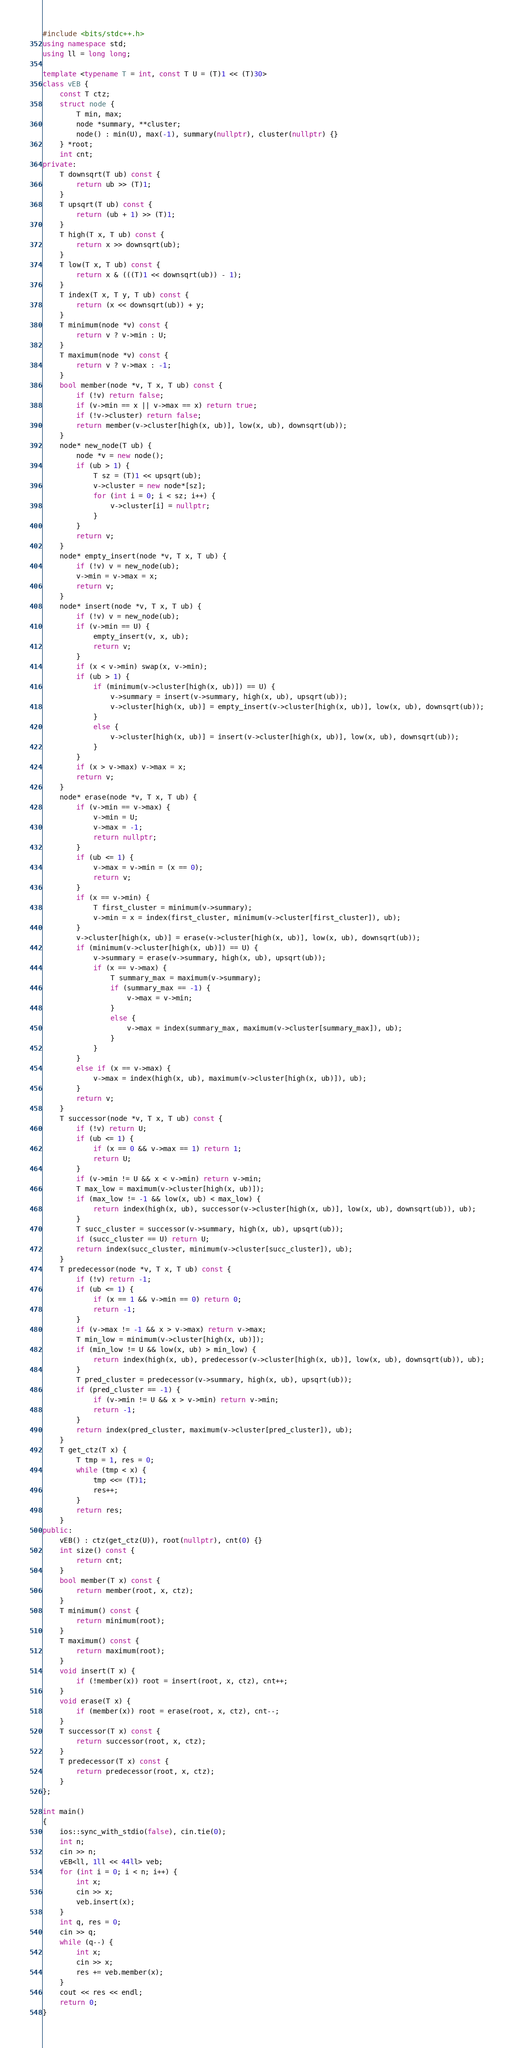Convert code to text. <code><loc_0><loc_0><loc_500><loc_500><_C++_>#include <bits/stdc++.h>
using namespace std;
using ll = long long;

template <typename T = int, const T U = (T)1 << (T)30>
class vEB {
	const T ctz;
	struct node {
		T min, max;
		node *summary, **cluster;
		node() : min(U), max(-1), summary(nullptr), cluster(nullptr) {}
	} *root;
	int cnt;
private:
	T downsqrt(T ub) const {
		return ub >> (T)1;
	}
	T upsqrt(T ub) const {
		return (ub + 1) >> (T)1;
	}
	T high(T x, T ub) const {
		return x >> downsqrt(ub);
	}
	T low(T x, T ub) const {
		return x & (((T)1 << downsqrt(ub)) - 1);
	}
	T index(T x, T y, T ub) const {
		return (x << downsqrt(ub)) + y;
	}
	T minimum(node *v) const {
		return v ? v->min : U;
	}
	T maximum(node *v) const {
		return v ? v->max : -1;
	}
	bool member(node *v, T x, T ub) const {
		if (!v) return false;
		if (v->min == x || v->max == x) return true;
		if (!v->cluster) return false;
		return member(v->cluster[high(x, ub)], low(x, ub), downsqrt(ub));
	}
	node* new_node(T ub) {
		node *v = new node();
		if (ub > 1) {
			T sz = (T)1 << upsqrt(ub);
			v->cluster = new node*[sz];
			for (int i = 0; i < sz; i++) {
				v->cluster[i] = nullptr;
			}
		}
		return v;
	}
	node* empty_insert(node *v, T x, T ub) {
		if (!v) v = new_node(ub);
		v->min = v->max = x;
		return v;
	}
	node* insert(node *v, T x, T ub) {
		if (!v) v = new_node(ub);
		if (v->min == U) {
			empty_insert(v, x, ub);
			return v;
		}
		if (x < v->min) swap(x, v->min);
		if (ub > 1) {
			if (minimum(v->cluster[high(x, ub)]) == U) {
				v->summary = insert(v->summary, high(x, ub), upsqrt(ub));
				v->cluster[high(x, ub)] = empty_insert(v->cluster[high(x, ub)], low(x, ub), downsqrt(ub));
			}
			else {
				v->cluster[high(x, ub)] = insert(v->cluster[high(x, ub)], low(x, ub), downsqrt(ub));
			}
		}
		if (x > v->max) v->max = x;
		return v;
	}
	node* erase(node *v, T x, T ub) {
		if (v->min == v->max) {
			v->min = U;
			v->max = -1;
			return nullptr;
		}
		if (ub <= 1) {
			v->max = v->min = (x == 0);
			return v;
		}
		if (x == v->min) {
			T first_cluster = minimum(v->summary);
			v->min = x = index(first_cluster, minimum(v->cluster[first_cluster]), ub);
		}
		v->cluster[high(x, ub)] = erase(v->cluster[high(x, ub)], low(x, ub), downsqrt(ub));
		if (minimum(v->cluster[high(x, ub)]) == U) {
			v->summary = erase(v->summary, high(x, ub), upsqrt(ub));
			if (x == v->max) {
				T summary_max = maximum(v->summary);
				if (summary_max == -1) {
					v->max = v->min;
				}
				else {
					v->max = index(summary_max, maximum(v->cluster[summary_max]), ub);
				}
			}
		}
		else if (x == v->max) {
			v->max = index(high(x, ub), maximum(v->cluster[high(x, ub)]), ub);
		}
		return v;
	}
	T successor(node *v, T x, T ub) const {
		if (!v) return U;
		if (ub <= 1) {
			if (x == 0 && v->max == 1) return 1;
			return U;
		}
		if (v->min != U && x < v->min) return v->min;
		T max_low = maximum(v->cluster[high(x, ub)]);
		if (max_low != -1 && low(x, ub) < max_low) {
			return index(high(x, ub), successor(v->cluster[high(x, ub)], low(x, ub), downsqrt(ub)), ub);
		}
		T succ_cluster = successor(v->summary, high(x, ub), upsqrt(ub));
		if (succ_cluster == U) return U;
		return index(succ_cluster, minimum(v->cluster[succ_cluster]), ub);
	}
	T predecessor(node *v, T x, T ub) const {
		if (!v) return -1;
		if (ub <= 1) {
			if (x == 1 && v->min == 0) return 0;
			return -1;
		}
		if (v->max != -1 && x > v->max) return v->max;
		T min_low = minimum(v->cluster[high(x, ub)]);
		if (min_low != U && low(x, ub) > min_low) {
			return index(high(x, ub), predecessor(v->cluster[high(x, ub)], low(x, ub), downsqrt(ub)), ub);
		}
		T pred_cluster = predecessor(v->summary, high(x, ub), upsqrt(ub));
		if (pred_cluster == -1) {
			if (v->min != U && x > v->min) return v->min;
			return -1;
		}
		return index(pred_cluster, maximum(v->cluster[pred_cluster]), ub);
	}
	T get_ctz(T x) {
		T tmp = 1, res = 0;
		while (tmp < x) {
			tmp <<= (T)1;
			res++;
		}
		return res;
	}
public:
	vEB() : ctz(get_ctz(U)), root(nullptr), cnt(0) {}
	int size() const {
		return cnt;
	}
	bool member(T x) const {
		return member(root, x, ctz);
	}
	T minimum() const {
		return minimum(root);
	}
	T maximum() const {
		return maximum(root);
	}
	void insert(T x) {
		if (!member(x)) root = insert(root, x, ctz), cnt++;
	}
	void erase(T x) {
		if (member(x)) root = erase(root, x, ctz), cnt--;
	}
	T successor(T x) const {
		return successor(root, x, ctz);
	}
	T predecessor(T x) const {
		return predecessor(root, x, ctz);
	}
};

int main()
{
	ios::sync_with_stdio(false), cin.tie(0);
	int n;
	cin >> n;
	vEB<ll, 1ll << 44ll> veb;
	for (int i = 0; i < n; i++) {
		int x;
		cin >> x;
		veb.insert(x);
	}
	int q, res = 0;
	cin >> q;
	while (q--) {
		int x;
		cin >> x;
		res += veb.member(x);
	}
	cout << res << endl;
	return 0;
}

</code> 